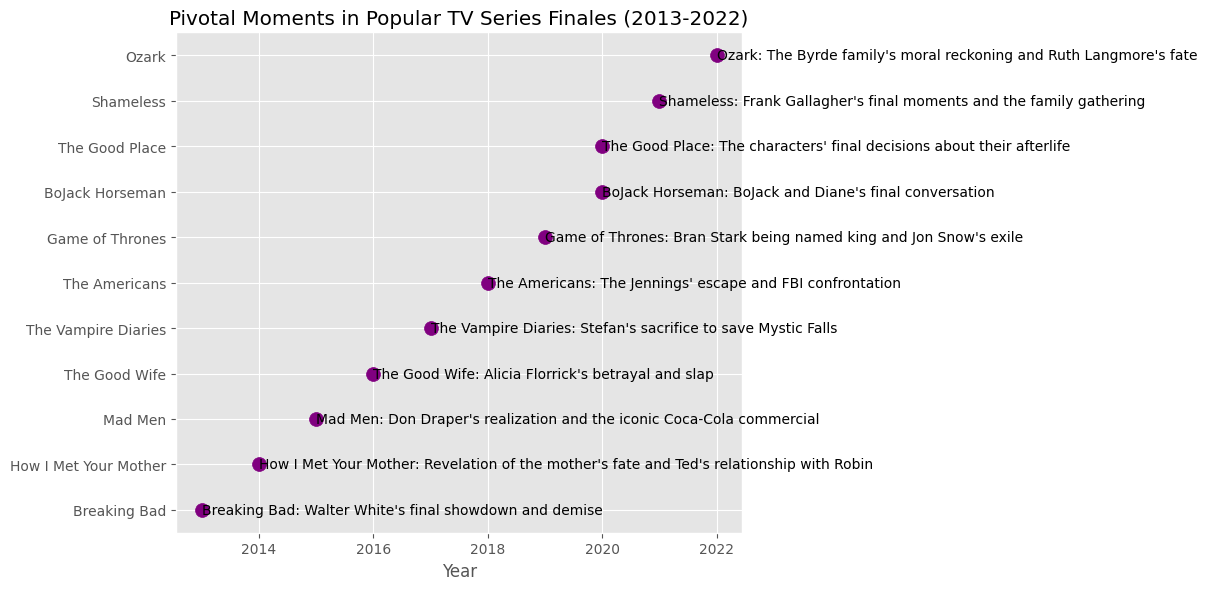Which TV series had the earliest finale date? Look at the dates alongside the TV series; find the earliest one. That's "Breaking Bad" on 2013-09-29.
Answer: Breaking Bad Which TV series had finales in the same year and what were the pivotal moments? Identify series that share the same year value. For 2020, it's "BoJack Horseman" and "The Good Place". Their pivotal moments are "BoJack and Diane's final conversation" and "The characters' final decisions about their afterlife" respectively.
Answer: BoJack Horseman: BoJack and Diane's final conversation; The Good Place: The characters' final decisions about their afterlife How many TV series finales occurred after 2018? Count the number of series finales with a year greater than 2018. There are four: "Game of Thrones", "Shameless", and "Ozark".
Answer: Four Which series' finale involved a major character's demise? Look for moments that signify a character's death. "Breaking Bad" (Walter White's demise), "The Vampire Diaries" (Stefan's sacrifice), and "Shameless" (Frank Gallagher's final moments) all fit this criterion.
Answer: Breaking Bad, The Vampire Diaries, Shameless Which TV series finale has the longest title for its pivotal moment? Compare the lengths of each pivotal moment description. "Revelation of the mother's fate and Ted's relationship with Robin" from "How I Met Your Mother" is the longest.
Answer: How I Met Your Mother 